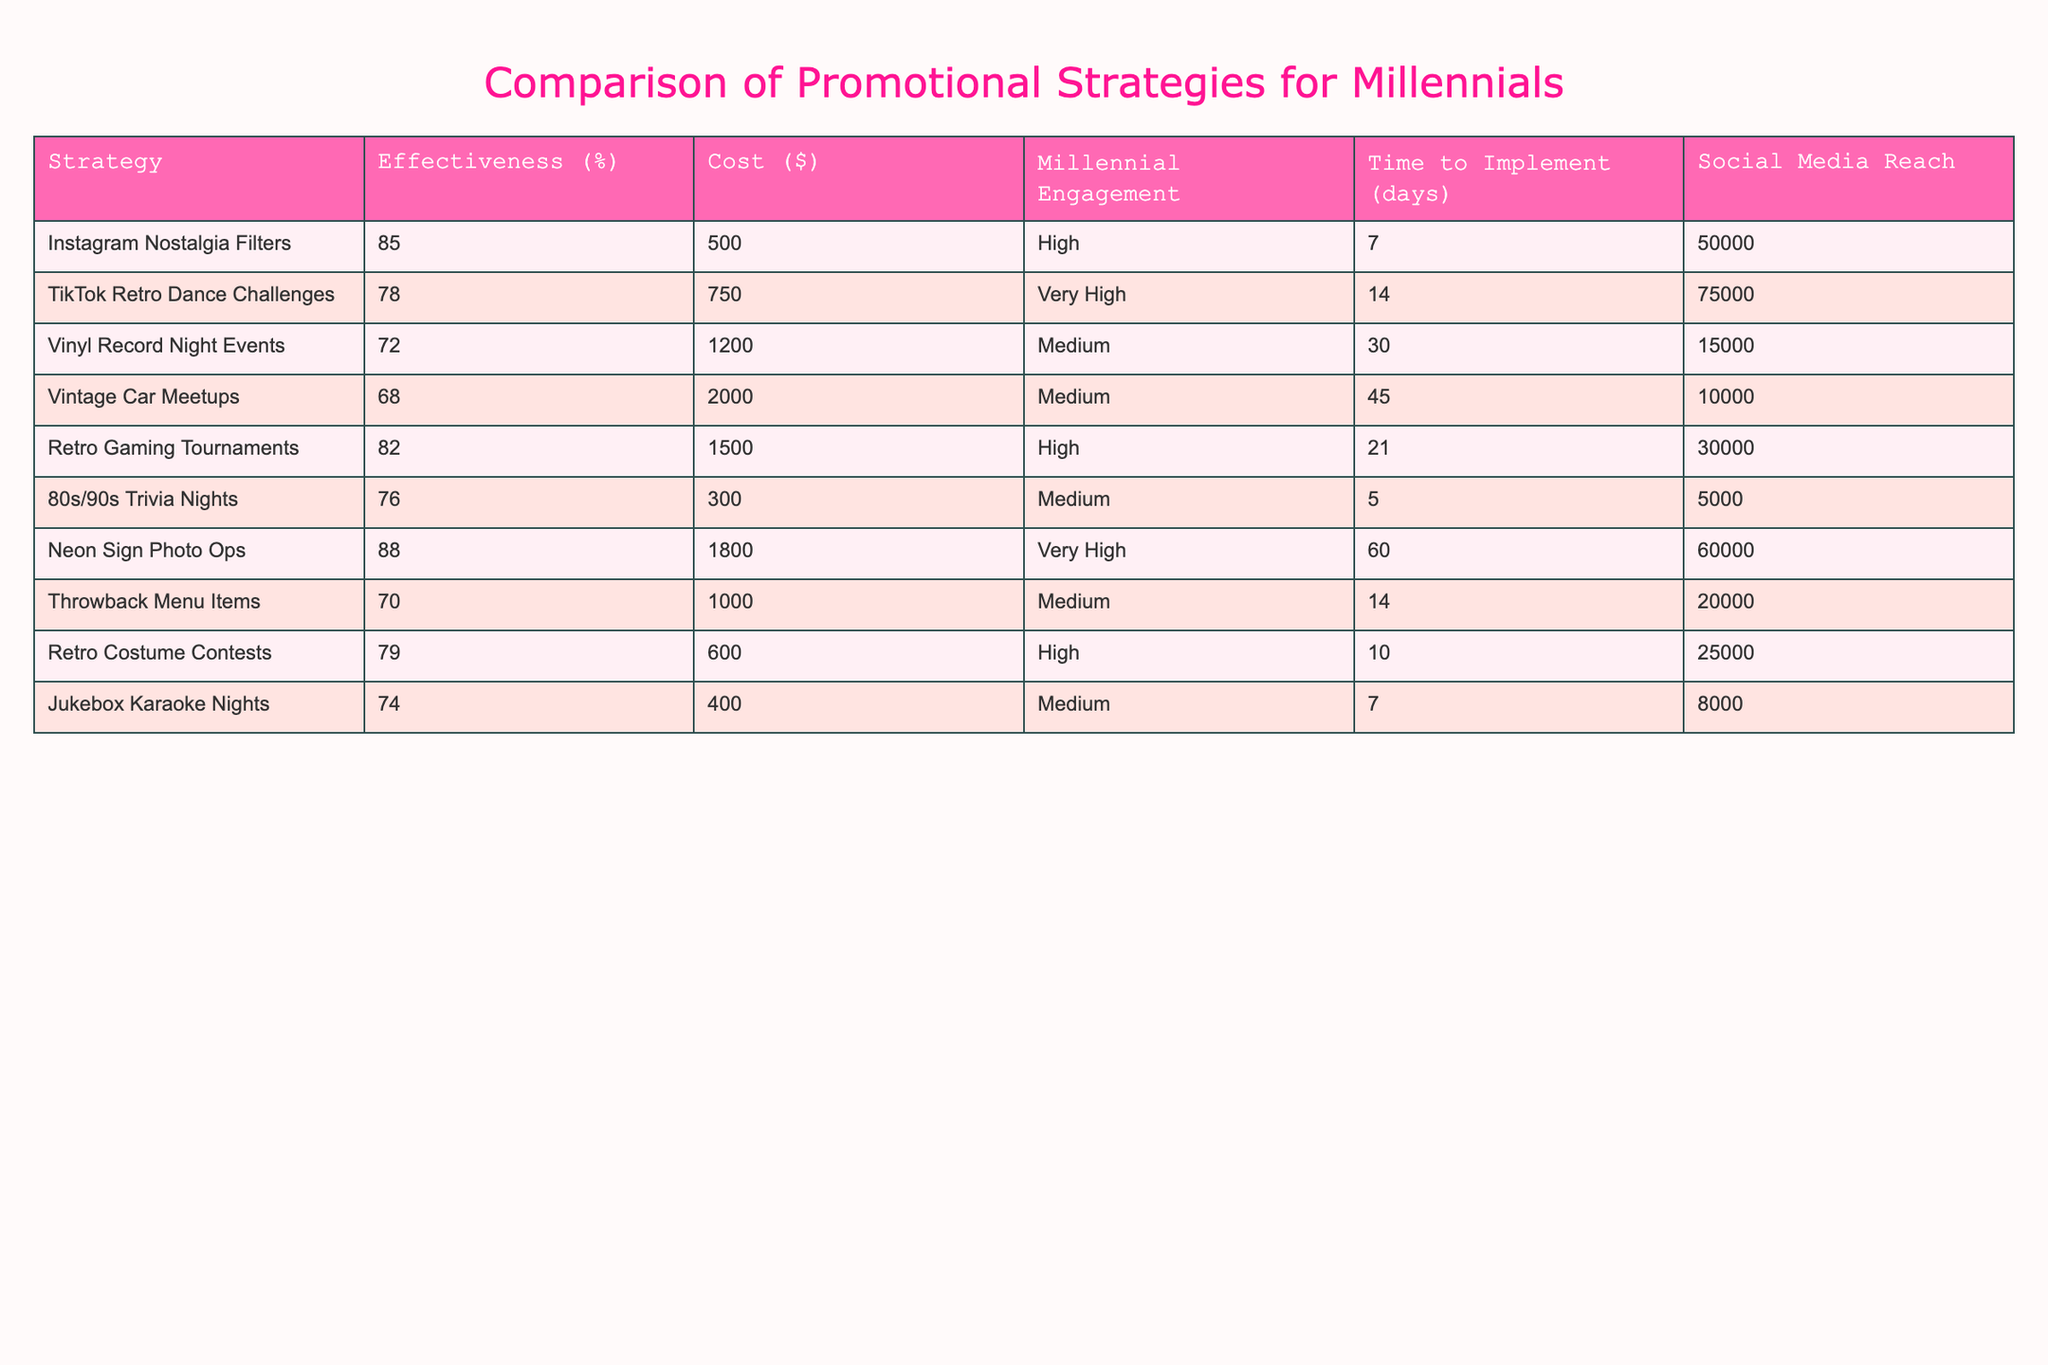What is the effectiveness percentage of the Instagram Nostalgia Filters strategy? The table lists the effectiveness percentage for each promotional strategy. For the Instagram Nostalgia Filters, the effectiveness percentage is explicitly noted as 85%.
Answer: 85% Which promotional strategy has the highest cost? By looking at the cost column, we identify the highest value. The Vinyl Record Night Events strategy has a cost of $1200, which is higher than all other strategies listed.
Answer: Vinyl Record Night Events What is the average effectiveness of the strategies with high engagement? First, we identify the strategies with high engagement: Instagram Nostalgia Filters, TikTok Retro Dance Challenges, Retro Gaming Tournaments, Neon Sign Photo Ops, Retro Costume Contests. Their effectiveness percentages are 85%, 78%, 82%, 88%, and 79%, respectively. The sum is 85 + 78 + 82 + 88 + 79 = 412. There are 5 strategies, so the average effectiveness is 412 / 5 = 82.4%.
Answer: 82.4% Is it true that the TikTok Retro Dance Challenges have a higher effectiveness than the Retro Gaming Tournaments? We compare the effectiveness percentages: TikTok Retro Dance Challenges is 78%, while Retro Gaming Tournaments is 82%. Since 78% is less than 82%, the statement is false.
Answer: No What is the total cost of the promotional strategies categorized as medium engagement? The strategies with medium engagement are Vinyl Record Night Events, Throwback Menu Items, and Jukebox Karaoke Nights, with costs of $1200, $1000, and $400 respectively. Adding these gives us a total cost of 1200 + 1000 + 400 = 2600.
Answer: 2600 Which strategy has the longest time to implement and what is its effectiveness percentage? The longest time to implement, as per the table, is 60 days for the Neon Sign Photo Ops strategy. Its effectiveness percentage is noted as 88%.
Answer: Neon Sign Photo Ops, 88% How many strategies have very high engagement and what are their effectiveness percentages? The strategies with very high engagement are Instagram Nostalgia Filters and Neon Sign Photo Ops, with effectiveness percentages of 85% and 88% respectively. Therefore, there are 2 strategies.
Answer: 2 strategies, 85%, 88% 